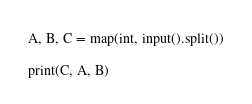Convert code to text. <code><loc_0><loc_0><loc_500><loc_500><_Python_>A, B, C = map(int, input().split())

print(C, A, B)</code> 